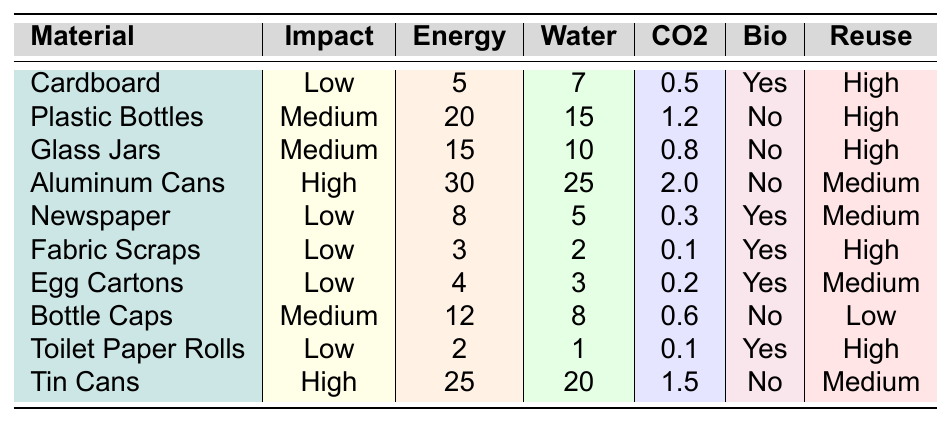What is the environmental impact of cardboard? The table lists "Low" as the environmental impact for cardboard in the respective column.
Answer: Low Which recycled material requires the least energy to recycle? The table shows that the material requiring the least energy to recycle is "Toilet Paper Rolls" with an energy value of 2.
Answer: Toilet Paper Rolls How much water is saved when recycling fabric scraps? According to the table, recycling fabric scraps saves 2 units of water.
Answer: 2 Do aluminum cans biodegrade? The table indicates that aluminum cans are marked with "No" for biodegradability.
Answer: No What is the CO2 reduction from recycling glass jars? The table lists the CO2 reduction for glass jars as 0.8.
Answer: 0.8 What is the average CO2 reduction of recycled materials with medium environmental impact? The medium-impact materials are plastic bottles, glass jars, and bottle caps, which have CO2 reductions of 1.2, 0.8, and 0.6 respectively. The average is (1.2 + 0.8 + 0.6) / 3 = 0.8667.
Answer: 0.8667 How many materials have a low environmental impact? The table shows there are four materials with a low environmental impact: cardboard, newspaper, fabric scraps, and toilet paper rolls.
Answer: 4 Which recycled material has the highest reuse potential? The table indicates that cardboard, plastic bottles, fabric scraps, and toilet paper rolls have a "High" reuse potential.
Answer: Cardboard, Plastic Bottles, Fabric Scraps, Toilet Paper Rolls If we consider all materials, what is the total energy required to recycle all of them? By summing the energy values (5 + 20 + 15 + 30 + 8 + 3 + 4 + 12 + 2 + 25), we get a total of 120.
Answer: 120 Which material saves the most water when recycled? The table shows that aluminum cans save the most water at 25 units.
Answer: Aluminum Cans 